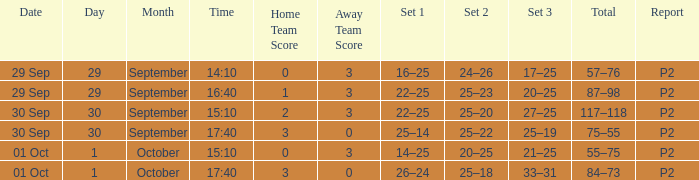What score is associated with a time of 14:10? 0–3. 